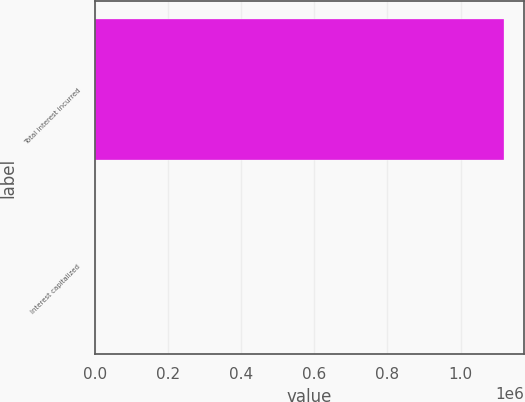Convert chart to OTSL. <chart><loc_0><loc_0><loc_500><loc_500><bar_chart><fcel>Total interest incurred<fcel>Interest capitalized<nl><fcel>1.11733e+06<fcel>969<nl></chart> 